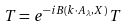Convert formula to latex. <formula><loc_0><loc_0><loc_500><loc_500>T = e ^ { - i B ( k \cdot A _ { \lambda } , X ) } \, T</formula> 